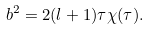<formula> <loc_0><loc_0><loc_500><loc_500>b ^ { 2 } = 2 ( l + 1 ) \tau \chi ( \tau ) .</formula> 